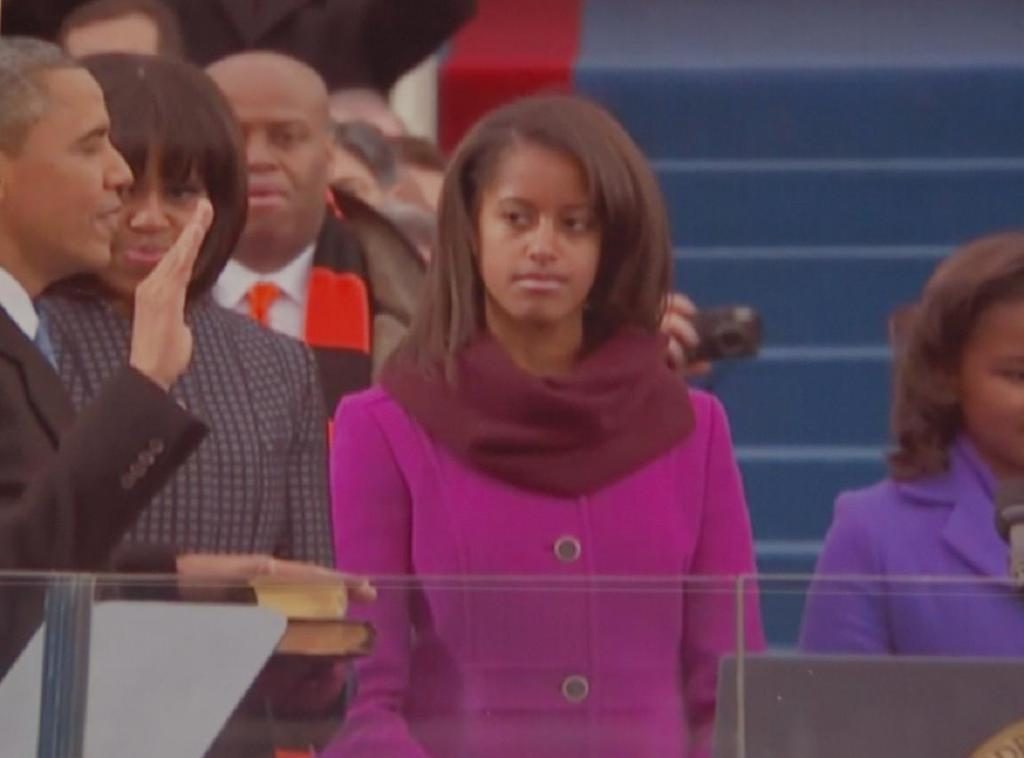What is happening in the image? There are people standing in the image. What can be seen in the background of the image? There are steps visible in the background of the image, as well as other objects. How many mice are visible on the steps in the image? There are no mice present in the image; only people and objects can be seen. 